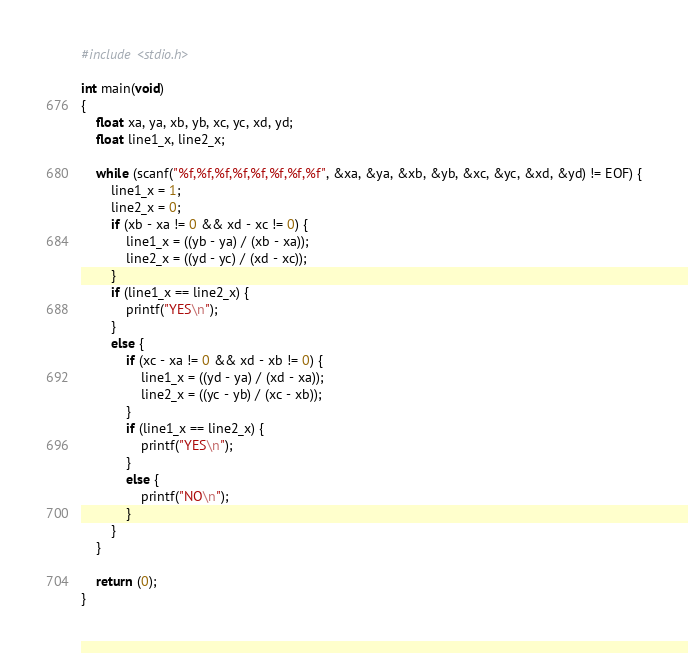Convert code to text. <code><loc_0><loc_0><loc_500><loc_500><_C_>#include <stdio.h>

int main(void)
{
	float xa, ya, xb, yb, xc, yc, xd, yd;
	float line1_x, line2_x;
	
	while (scanf("%f,%f,%f,%f,%f,%f,%f,%f", &xa, &ya, &xb, &yb, &xc, &yc, &xd, &yd) != EOF) {
		line1_x = 1;
		line2_x = 0;
		if (xb - xa != 0 && xd - xc != 0) {
			line1_x = ((yb - ya) / (xb - xa));
			line2_x = ((yd - yc) / (xd - xc));
		}
		if (line1_x == line2_x) {
			printf("YES\n");
		}
		else {
			if (xc - xa != 0 && xd - xb != 0) {
				line1_x = ((yd - ya) / (xd - xa));
				line2_x = ((yc - yb) / (xc - xb));
			}
			if (line1_x == line2_x) {
				printf("YES\n");
			}
			else {
				printf("NO\n");
			}
		}
	}
	
	return (0);
}</code> 